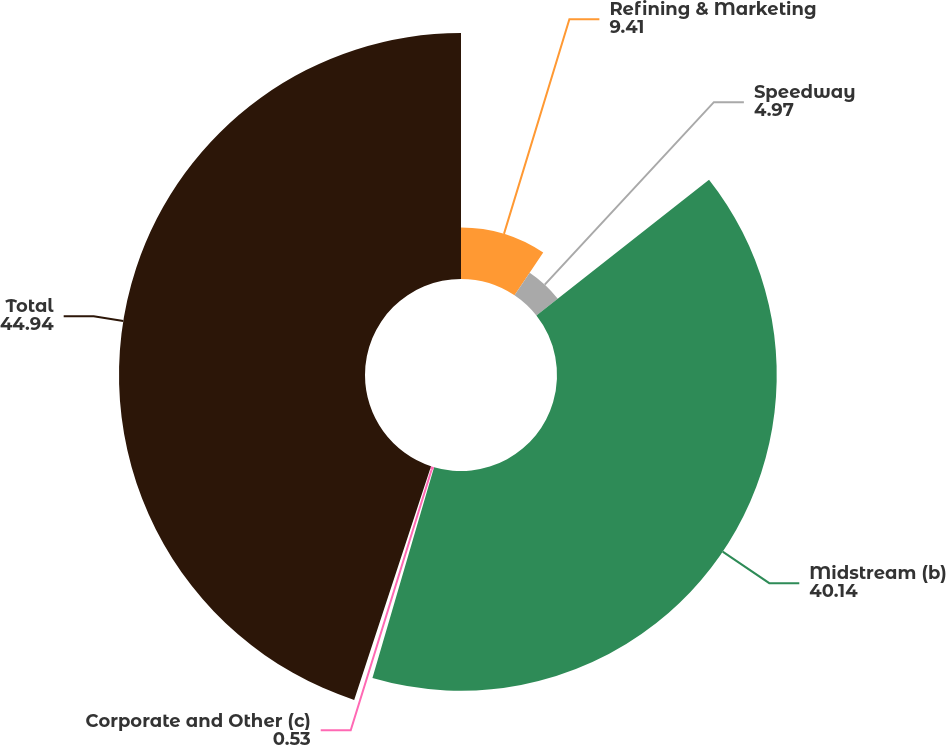<chart> <loc_0><loc_0><loc_500><loc_500><pie_chart><fcel>Refining & Marketing<fcel>Speedway<fcel>Midstream (b)<fcel>Corporate and Other (c)<fcel>Total<nl><fcel>9.41%<fcel>4.97%<fcel>40.14%<fcel>0.53%<fcel>44.94%<nl></chart> 